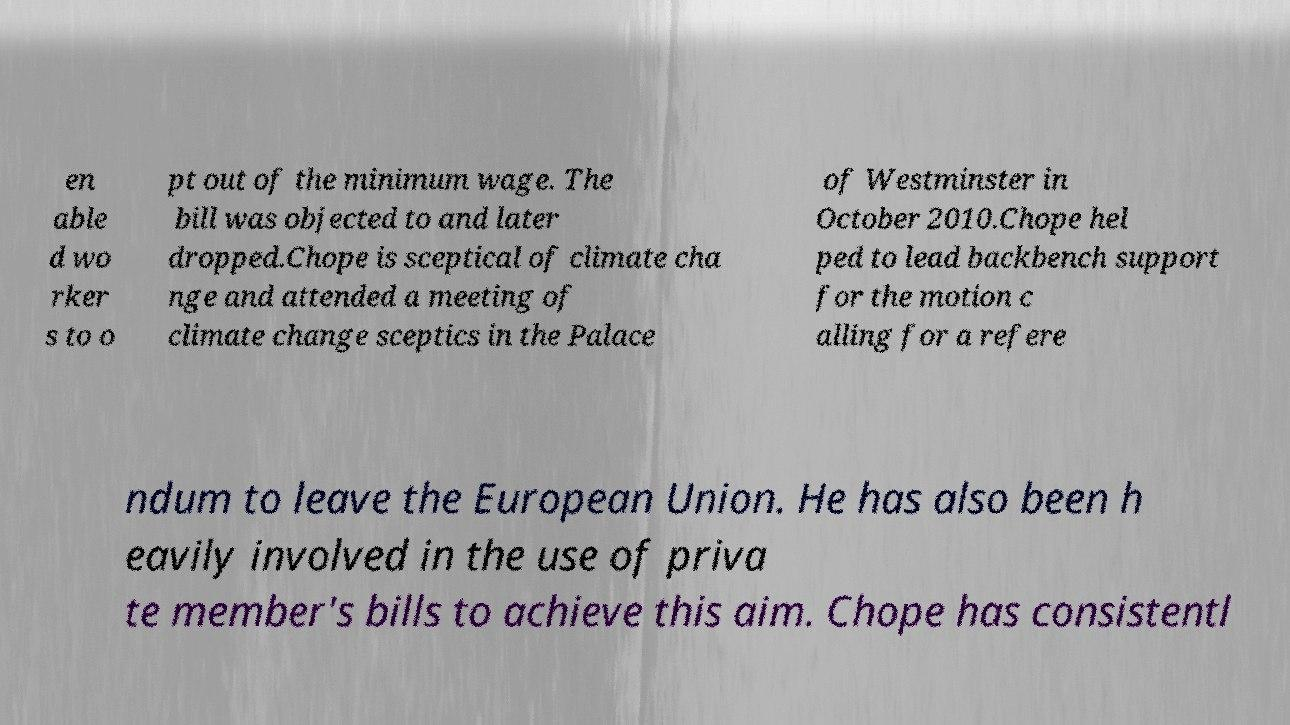Can you accurately transcribe the text from the provided image for me? en able d wo rker s to o pt out of the minimum wage. The bill was objected to and later dropped.Chope is sceptical of climate cha nge and attended a meeting of climate change sceptics in the Palace of Westminster in October 2010.Chope hel ped to lead backbench support for the motion c alling for a refere ndum to leave the European Union. He has also been h eavily involved in the use of priva te member's bills to achieve this aim. Chope has consistentl 